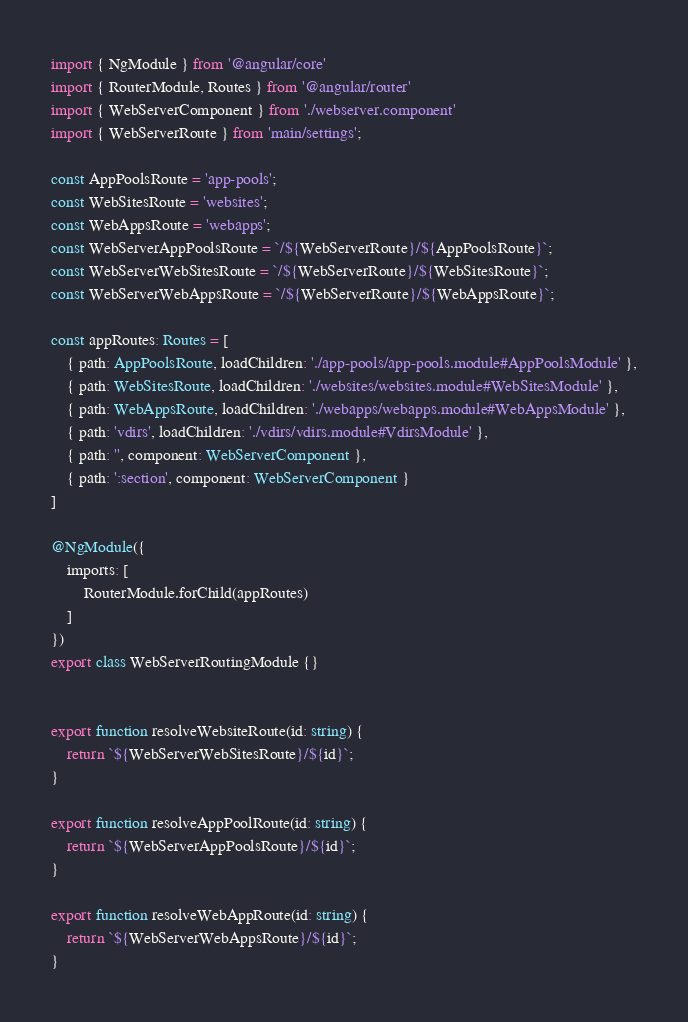Convert code to text. <code><loc_0><loc_0><loc_500><loc_500><_TypeScript_>import { NgModule } from '@angular/core'
import { RouterModule, Routes } from '@angular/router'
import { WebServerComponent } from './webserver.component'
import { WebServerRoute } from 'main/settings';

const AppPoolsRoute = 'app-pools';
const WebSitesRoute = 'websites';
const WebAppsRoute = 'webapps';
const WebServerAppPoolsRoute = `/${WebServerRoute}/${AppPoolsRoute}`;
const WebServerWebSitesRoute = `/${WebServerRoute}/${WebSitesRoute}`;
const WebServerWebAppsRoute = `/${WebServerRoute}/${WebAppsRoute}`;

const appRoutes: Routes = [
    { path: AppPoolsRoute, loadChildren: './app-pools/app-pools.module#AppPoolsModule' },
    { path: WebSitesRoute, loadChildren: './websites/websites.module#WebSitesModule' },
    { path: WebAppsRoute, loadChildren: './webapps/webapps.module#WebAppsModule' },
    { path: 'vdirs', loadChildren: './vdirs/vdirs.module#VdirsModule' },
    { path: '', component: WebServerComponent },
    { path: ':section', component: WebServerComponent }
]

@NgModule({
    imports: [
        RouterModule.forChild(appRoutes)
    ]
})
export class WebServerRoutingModule {}


export function resolveWebsiteRoute(id: string) {
    return `${WebServerWebSitesRoute}/${id}`;
}

export function resolveAppPoolRoute(id: string) {
    return `${WebServerAppPoolsRoute}/${id}`;
}

export function resolveWebAppRoute(id: string) {
    return `${WebServerWebAppsRoute}/${id}`;
}
</code> 